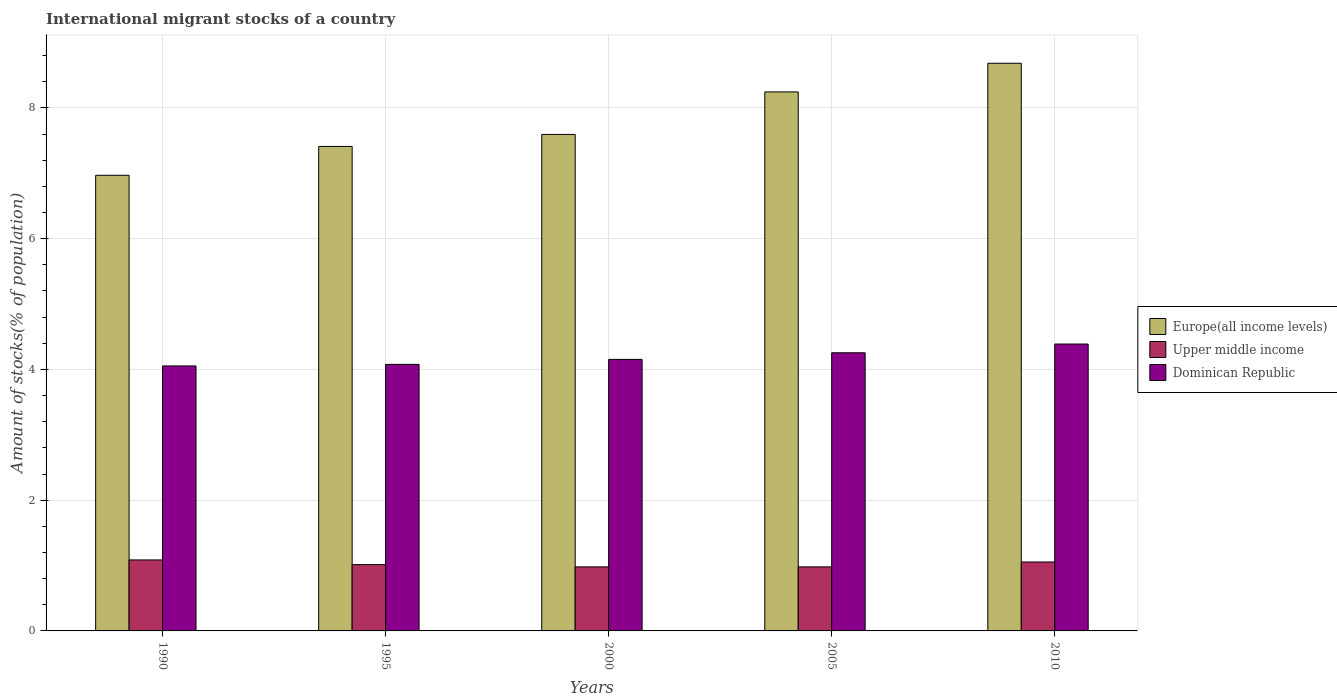Are the number of bars per tick equal to the number of legend labels?
Offer a very short reply. Yes. How many bars are there on the 4th tick from the left?
Provide a succinct answer. 3. How many bars are there on the 5th tick from the right?
Keep it short and to the point. 3. In how many cases, is the number of bars for a given year not equal to the number of legend labels?
Keep it short and to the point. 0. What is the amount of stocks in in Europe(all income levels) in 1990?
Your response must be concise. 6.97. Across all years, what is the maximum amount of stocks in in Europe(all income levels)?
Your answer should be compact. 8.68. Across all years, what is the minimum amount of stocks in in Upper middle income?
Offer a terse response. 0.98. What is the total amount of stocks in in Upper middle income in the graph?
Provide a short and direct response. 5.11. What is the difference between the amount of stocks in in Dominican Republic in 1990 and that in 2005?
Provide a short and direct response. -0.2. What is the difference between the amount of stocks in in Upper middle income in 2000 and the amount of stocks in in Dominican Republic in 2010?
Your answer should be very brief. -3.41. What is the average amount of stocks in in Dominican Republic per year?
Give a very brief answer. 4.19. In the year 2000, what is the difference between the amount of stocks in in Upper middle income and amount of stocks in in Europe(all income levels)?
Your response must be concise. -6.61. In how many years, is the amount of stocks in in Upper middle income greater than 2.8 %?
Provide a short and direct response. 0. What is the ratio of the amount of stocks in in Dominican Republic in 1990 to that in 2000?
Provide a succinct answer. 0.98. Is the amount of stocks in in Upper middle income in 1995 less than that in 2005?
Offer a very short reply. No. Is the difference between the amount of stocks in in Upper middle income in 1990 and 2005 greater than the difference between the amount of stocks in in Europe(all income levels) in 1990 and 2005?
Your answer should be compact. Yes. What is the difference between the highest and the second highest amount of stocks in in Upper middle income?
Provide a succinct answer. 0.03. What is the difference between the highest and the lowest amount of stocks in in Upper middle income?
Your answer should be very brief. 0.11. In how many years, is the amount of stocks in in Dominican Republic greater than the average amount of stocks in in Dominican Republic taken over all years?
Your answer should be very brief. 2. What does the 2nd bar from the left in 2000 represents?
Give a very brief answer. Upper middle income. What does the 1st bar from the right in 1995 represents?
Provide a succinct answer. Dominican Republic. Is it the case that in every year, the sum of the amount of stocks in in Dominican Republic and amount of stocks in in Upper middle income is greater than the amount of stocks in in Europe(all income levels)?
Offer a very short reply. No. What is the difference between two consecutive major ticks on the Y-axis?
Provide a succinct answer. 2. Where does the legend appear in the graph?
Your answer should be very brief. Center right. How many legend labels are there?
Provide a succinct answer. 3. How are the legend labels stacked?
Ensure brevity in your answer.  Vertical. What is the title of the graph?
Your answer should be compact. International migrant stocks of a country. Does "Kiribati" appear as one of the legend labels in the graph?
Provide a short and direct response. No. What is the label or title of the X-axis?
Provide a succinct answer. Years. What is the label or title of the Y-axis?
Give a very brief answer. Amount of stocks(% of population). What is the Amount of stocks(% of population) of Europe(all income levels) in 1990?
Keep it short and to the point. 6.97. What is the Amount of stocks(% of population) of Upper middle income in 1990?
Provide a short and direct response. 1.09. What is the Amount of stocks(% of population) in Dominican Republic in 1990?
Your response must be concise. 4.05. What is the Amount of stocks(% of population) in Europe(all income levels) in 1995?
Give a very brief answer. 7.41. What is the Amount of stocks(% of population) in Upper middle income in 1995?
Give a very brief answer. 1.01. What is the Amount of stocks(% of population) in Dominican Republic in 1995?
Make the answer very short. 4.08. What is the Amount of stocks(% of population) of Europe(all income levels) in 2000?
Provide a succinct answer. 7.59. What is the Amount of stocks(% of population) in Upper middle income in 2000?
Offer a very short reply. 0.98. What is the Amount of stocks(% of population) in Dominican Republic in 2000?
Provide a succinct answer. 4.15. What is the Amount of stocks(% of population) of Europe(all income levels) in 2005?
Offer a terse response. 8.24. What is the Amount of stocks(% of population) in Upper middle income in 2005?
Your answer should be very brief. 0.98. What is the Amount of stocks(% of population) in Dominican Republic in 2005?
Your answer should be very brief. 4.25. What is the Amount of stocks(% of population) in Europe(all income levels) in 2010?
Provide a succinct answer. 8.68. What is the Amount of stocks(% of population) in Upper middle income in 2010?
Make the answer very short. 1.05. What is the Amount of stocks(% of population) in Dominican Republic in 2010?
Your answer should be very brief. 4.39. Across all years, what is the maximum Amount of stocks(% of population) in Europe(all income levels)?
Offer a very short reply. 8.68. Across all years, what is the maximum Amount of stocks(% of population) of Upper middle income?
Offer a very short reply. 1.09. Across all years, what is the maximum Amount of stocks(% of population) of Dominican Republic?
Offer a very short reply. 4.39. Across all years, what is the minimum Amount of stocks(% of population) in Europe(all income levels)?
Provide a short and direct response. 6.97. Across all years, what is the minimum Amount of stocks(% of population) of Upper middle income?
Provide a short and direct response. 0.98. Across all years, what is the minimum Amount of stocks(% of population) in Dominican Republic?
Keep it short and to the point. 4.05. What is the total Amount of stocks(% of population) of Europe(all income levels) in the graph?
Provide a short and direct response. 38.9. What is the total Amount of stocks(% of population) in Upper middle income in the graph?
Make the answer very short. 5.11. What is the total Amount of stocks(% of population) of Dominican Republic in the graph?
Keep it short and to the point. 20.93. What is the difference between the Amount of stocks(% of population) in Europe(all income levels) in 1990 and that in 1995?
Keep it short and to the point. -0.44. What is the difference between the Amount of stocks(% of population) of Upper middle income in 1990 and that in 1995?
Ensure brevity in your answer.  0.07. What is the difference between the Amount of stocks(% of population) of Dominican Republic in 1990 and that in 1995?
Your answer should be compact. -0.02. What is the difference between the Amount of stocks(% of population) of Europe(all income levels) in 1990 and that in 2000?
Your answer should be compact. -0.62. What is the difference between the Amount of stocks(% of population) in Upper middle income in 1990 and that in 2000?
Your answer should be compact. 0.11. What is the difference between the Amount of stocks(% of population) of Dominican Republic in 1990 and that in 2000?
Offer a very short reply. -0.1. What is the difference between the Amount of stocks(% of population) in Europe(all income levels) in 1990 and that in 2005?
Give a very brief answer. -1.28. What is the difference between the Amount of stocks(% of population) of Upper middle income in 1990 and that in 2005?
Offer a terse response. 0.11. What is the difference between the Amount of stocks(% of population) of Dominican Republic in 1990 and that in 2005?
Offer a terse response. -0.2. What is the difference between the Amount of stocks(% of population) of Europe(all income levels) in 1990 and that in 2010?
Your answer should be very brief. -1.71. What is the difference between the Amount of stocks(% of population) of Upper middle income in 1990 and that in 2010?
Offer a very short reply. 0.03. What is the difference between the Amount of stocks(% of population) in Dominican Republic in 1990 and that in 2010?
Keep it short and to the point. -0.34. What is the difference between the Amount of stocks(% of population) of Europe(all income levels) in 1995 and that in 2000?
Provide a short and direct response. -0.18. What is the difference between the Amount of stocks(% of population) in Upper middle income in 1995 and that in 2000?
Make the answer very short. 0.03. What is the difference between the Amount of stocks(% of population) in Dominican Republic in 1995 and that in 2000?
Your answer should be very brief. -0.08. What is the difference between the Amount of stocks(% of population) in Europe(all income levels) in 1995 and that in 2005?
Offer a very short reply. -0.83. What is the difference between the Amount of stocks(% of population) in Upper middle income in 1995 and that in 2005?
Give a very brief answer. 0.04. What is the difference between the Amount of stocks(% of population) in Dominican Republic in 1995 and that in 2005?
Your answer should be very brief. -0.18. What is the difference between the Amount of stocks(% of population) in Europe(all income levels) in 1995 and that in 2010?
Offer a terse response. -1.27. What is the difference between the Amount of stocks(% of population) in Upper middle income in 1995 and that in 2010?
Keep it short and to the point. -0.04. What is the difference between the Amount of stocks(% of population) in Dominican Republic in 1995 and that in 2010?
Provide a short and direct response. -0.31. What is the difference between the Amount of stocks(% of population) in Europe(all income levels) in 2000 and that in 2005?
Offer a very short reply. -0.65. What is the difference between the Amount of stocks(% of population) of Upper middle income in 2000 and that in 2005?
Your answer should be compact. 0. What is the difference between the Amount of stocks(% of population) in Dominican Republic in 2000 and that in 2005?
Your answer should be compact. -0.1. What is the difference between the Amount of stocks(% of population) of Europe(all income levels) in 2000 and that in 2010?
Provide a succinct answer. -1.09. What is the difference between the Amount of stocks(% of population) of Upper middle income in 2000 and that in 2010?
Keep it short and to the point. -0.07. What is the difference between the Amount of stocks(% of population) of Dominican Republic in 2000 and that in 2010?
Provide a succinct answer. -0.24. What is the difference between the Amount of stocks(% of population) of Europe(all income levels) in 2005 and that in 2010?
Your response must be concise. -0.44. What is the difference between the Amount of stocks(% of population) of Upper middle income in 2005 and that in 2010?
Give a very brief answer. -0.07. What is the difference between the Amount of stocks(% of population) in Dominican Republic in 2005 and that in 2010?
Keep it short and to the point. -0.13. What is the difference between the Amount of stocks(% of population) of Europe(all income levels) in 1990 and the Amount of stocks(% of population) of Upper middle income in 1995?
Give a very brief answer. 5.96. What is the difference between the Amount of stocks(% of population) of Europe(all income levels) in 1990 and the Amount of stocks(% of population) of Dominican Republic in 1995?
Give a very brief answer. 2.89. What is the difference between the Amount of stocks(% of population) in Upper middle income in 1990 and the Amount of stocks(% of population) in Dominican Republic in 1995?
Provide a succinct answer. -2.99. What is the difference between the Amount of stocks(% of population) of Europe(all income levels) in 1990 and the Amount of stocks(% of population) of Upper middle income in 2000?
Keep it short and to the point. 5.99. What is the difference between the Amount of stocks(% of population) in Europe(all income levels) in 1990 and the Amount of stocks(% of population) in Dominican Republic in 2000?
Offer a terse response. 2.82. What is the difference between the Amount of stocks(% of population) in Upper middle income in 1990 and the Amount of stocks(% of population) in Dominican Republic in 2000?
Keep it short and to the point. -3.07. What is the difference between the Amount of stocks(% of population) of Europe(all income levels) in 1990 and the Amount of stocks(% of population) of Upper middle income in 2005?
Your answer should be very brief. 5.99. What is the difference between the Amount of stocks(% of population) of Europe(all income levels) in 1990 and the Amount of stocks(% of population) of Dominican Republic in 2005?
Your answer should be compact. 2.71. What is the difference between the Amount of stocks(% of population) of Upper middle income in 1990 and the Amount of stocks(% of population) of Dominican Republic in 2005?
Give a very brief answer. -3.17. What is the difference between the Amount of stocks(% of population) in Europe(all income levels) in 1990 and the Amount of stocks(% of population) in Upper middle income in 2010?
Your answer should be compact. 5.92. What is the difference between the Amount of stocks(% of population) of Europe(all income levels) in 1990 and the Amount of stocks(% of population) of Dominican Republic in 2010?
Ensure brevity in your answer.  2.58. What is the difference between the Amount of stocks(% of population) of Upper middle income in 1990 and the Amount of stocks(% of population) of Dominican Republic in 2010?
Provide a succinct answer. -3.3. What is the difference between the Amount of stocks(% of population) of Europe(all income levels) in 1995 and the Amount of stocks(% of population) of Upper middle income in 2000?
Offer a very short reply. 6.43. What is the difference between the Amount of stocks(% of population) in Europe(all income levels) in 1995 and the Amount of stocks(% of population) in Dominican Republic in 2000?
Provide a succinct answer. 3.26. What is the difference between the Amount of stocks(% of population) of Upper middle income in 1995 and the Amount of stocks(% of population) of Dominican Republic in 2000?
Make the answer very short. -3.14. What is the difference between the Amount of stocks(% of population) in Europe(all income levels) in 1995 and the Amount of stocks(% of population) in Upper middle income in 2005?
Make the answer very short. 6.43. What is the difference between the Amount of stocks(% of population) in Europe(all income levels) in 1995 and the Amount of stocks(% of population) in Dominican Republic in 2005?
Your answer should be very brief. 3.16. What is the difference between the Amount of stocks(% of population) of Upper middle income in 1995 and the Amount of stocks(% of population) of Dominican Republic in 2005?
Keep it short and to the point. -3.24. What is the difference between the Amount of stocks(% of population) in Europe(all income levels) in 1995 and the Amount of stocks(% of population) in Upper middle income in 2010?
Ensure brevity in your answer.  6.36. What is the difference between the Amount of stocks(% of population) in Europe(all income levels) in 1995 and the Amount of stocks(% of population) in Dominican Republic in 2010?
Your answer should be compact. 3.02. What is the difference between the Amount of stocks(% of population) in Upper middle income in 1995 and the Amount of stocks(% of population) in Dominican Republic in 2010?
Your answer should be compact. -3.37. What is the difference between the Amount of stocks(% of population) of Europe(all income levels) in 2000 and the Amount of stocks(% of population) of Upper middle income in 2005?
Make the answer very short. 6.62. What is the difference between the Amount of stocks(% of population) of Europe(all income levels) in 2000 and the Amount of stocks(% of population) of Dominican Republic in 2005?
Make the answer very short. 3.34. What is the difference between the Amount of stocks(% of population) of Upper middle income in 2000 and the Amount of stocks(% of population) of Dominican Republic in 2005?
Keep it short and to the point. -3.27. What is the difference between the Amount of stocks(% of population) of Europe(all income levels) in 2000 and the Amount of stocks(% of population) of Upper middle income in 2010?
Keep it short and to the point. 6.54. What is the difference between the Amount of stocks(% of population) in Europe(all income levels) in 2000 and the Amount of stocks(% of population) in Dominican Republic in 2010?
Ensure brevity in your answer.  3.21. What is the difference between the Amount of stocks(% of population) in Upper middle income in 2000 and the Amount of stocks(% of population) in Dominican Republic in 2010?
Your answer should be very brief. -3.41. What is the difference between the Amount of stocks(% of population) of Europe(all income levels) in 2005 and the Amount of stocks(% of population) of Upper middle income in 2010?
Ensure brevity in your answer.  7.19. What is the difference between the Amount of stocks(% of population) in Europe(all income levels) in 2005 and the Amount of stocks(% of population) in Dominican Republic in 2010?
Ensure brevity in your answer.  3.86. What is the difference between the Amount of stocks(% of population) of Upper middle income in 2005 and the Amount of stocks(% of population) of Dominican Republic in 2010?
Ensure brevity in your answer.  -3.41. What is the average Amount of stocks(% of population) of Europe(all income levels) per year?
Ensure brevity in your answer.  7.78. What is the average Amount of stocks(% of population) of Upper middle income per year?
Make the answer very short. 1.02. What is the average Amount of stocks(% of population) in Dominican Republic per year?
Keep it short and to the point. 4.19. In the year 1990, what is the difference between the Amount of stocks(% of population) in Europe(all income levels) and Amount of stocks(% of population) in Upper middle income?
Give a very brief answer. 5.88. In the year 1990, what is the difference between the Amount of stocks(% of population) in Europe(all income levels) and Amount of stocks(% of population) in Dominican Republic?
Ensure brevity in your answer.  2.92. In the year 1990, what is the difference between the Amount of stocks(% of population) of Upper middle income and Amount of stocks(% of population) of Dominican Republic?
Your response must be concise. -2.97. In the year 1995, what is the difference between the Amount of stocks(% of population) of Europe(all income levels) and Amount of stocks(% of population) of Upper middle income?
Offer a very short reply. 6.4. In the year 1995, what is the difference between the Amount of stocks(% of population) in Europe(all income levels) and Amount of stocks(% of population) in Dominican Republic?
Provide a succinct answer. 3.33. In the year 1995, what is the difference between the Amount of stocks(% of population) of Upper middle income and Amount of stocks(% of population) of Dominican Republic?
Give a very brief answer. -3.06. In the year 2000, what is the difference between the Amount of stocks(% of population) in Europe(all income levels) and Amount of stocks(% of population) in Upper middle income?
Give a very brief answer. 6.61. In the year 2000, what is the difference between the Amount of stocks(% of population) of Europe(all income levels) and Amount of stocks(% of population) of Dominican Republic?
Offer a terse response. 3.44. In the year 2000, what is the difference between the Amount of stocks(% of population) in Upper middle income and Amount of stocks(% of population) in Dominican Republic?
Your answer should be very brief. -3.17. In the year 2005, what is the difference between the Amount of stocks(% of population) in Europe(all income levels) and Amount of stocks(% of population) in Upper middle income?
Provide a short and direct response. 7.27. In the year 2005, what is the difference between the Amount of stocks(% of population) in Europe(all income levels) and Amount of stocks(% of population) in Dominican Republic?
Your answer should be compact. 3.99. In the year 2005, what is the difference between the Amount of stocks(% of population) in Upper middle income and Amount of stocks(% of population) in Dominican Republic?
Your response must be concise. -3.28. In the year 2010, what is the difference between the Amount of stocks(% of population) in Europe(all income levels) and Amount of stocks(% of population) in Upper middle income?
Provide a short and direct response. 7.63. In the year 2010, what is the difference between the Amount of stocks(% of population) of Europe(all income levels) and Amount of stocks(% of population) of Dominican Republic?
Offer a terse response. 4.29. In the year 2010, what is the difference between the Amount of stocks(% of population) of Upper middle income and Amount of stocks(% of population) of Dominican Republic?
Give a very brief answer. -3.33. What is the ratio of the Amount of stocks(% of population) of Europe(all income levels) in 1990 to that in 1995?
Offer a very short reply. 0.94. What is the ratio of the Amount of stocks(% of population) of Upper middle income in 1990 to that in 1995?
Provide a succinct answer. 1.07. What is the ratio of the Amount of stocks(% of population) of Dominican Republic in 1990 to that in 1995?
Your answer should be compact. 0.99. What is the ratio of the Amount of stocks(% of population) of Europe(all income levels) in 1990 to that in 2000?
Offer a very short reply. 0.92. What is the ratio of the Amount of stocks(% of population) of Upper middle income in 1990 to that in 2000?
Give a very brief answer. 1.11. What is the ratio of the Amount of stocks(% of population) in Dominican Republic in 1990 to that in 2000?
Offer a very short reply. 0.98. What is the ratio of the Amount of stocks(% of population) in Europe(all income levels) in 1990 to that in 2005?
Provide a succinct answer. 0.85. What is the ratio of the Amount of stocks(% of population) in Upper middle income in 1990 to that in 2005?
Keep it short and to the point. 1.11. What is the ratio of the Amount of stocks(% of population) in Dominican Republic in 1990 to that in 2005?
Your response must be concise. 0.95. What is the ratio of the Amount of stocks(% of population) of Europe(all income levels) in 1990 to that in 2010?
Keep it short and to the point. 0.8. What is the ratio of the Amount of stocks(% of population) in Dominican Republic in 1990 to that in 2010?
Keep it short and to the point. 0.92. What is the ratio of the Amount of stocks(% of population) of Europe(all income levels) in 1995 to that in 2000?
Your response must be concise. 0.98. What is the ratio of the Amount of stocks(% of population) in Upper middle income in 1995 to that in 2000?
Your answer should be compact. 1.04. What is the ratio of the Amount of stocks(% of population) in Dominican Republic in 1995 to that in 2000?
Offer a very short reply. 0.98. What is the ratio of the Amount of stocks(% of population) of Europe(all income levels) in 1995 to that in 2005?
Provide a short and direct response. 0.9. What is the ratio of the Amount of stocks(% of population) of Upper middle income in 1995 to that in 2005?
Your answer should be very brief. 1.04. What is the ratio of the Amount of stocks(% of population) of Dominican Republic in 1995 to that in 2005?
Ensure brevity in your answer.  0.96. What is the ratio of the Amount of stocks(% of population) in Europe(all income levels) in 1995 to that in 2010?
Your response must be concise. 0.85. What is the ratio of the Amount of stocks(% of population) in Upper middle income in 1995 to that in 2010?
Ensure brevity in your answer.  0.96. What is the ratio of the Amount of stocks(% of population) of Dominican Republic in 1995 to that in 2010?
Your response must be concise. 0.93. What is the ratio of the Amount of stocks(% of population) of Europe(all income levels) in 2000 to that in 2005?
Offer a terse response. 0.92. What is the ratio of the Amount of stocks(% of population) of Upper middle income in 2000 to that in 2005?
Your answer should be compact. 1. What is the ratio of the Amount of stocks(% of population) in Dominican Republic in 2000 to that in 2005?
Your response must be concise. 0.98. What is the ratio of the Amount of stocks(% of population) in Europe(all income levels) in 2000 to that in 2010?
Give a very brief answer. 0.87. What is the ratio of the Amount of stocks(% of population) in Upper middle income in 2000 to that in 2010?
Offer a terse response. 0.93. What is the ratio of the Amount of stocks(% of population) of Dominican Republic in 2000 to that in 2010?
Make the answer very short. 0.95. What is the ratio of the Amount of stocks(% of population) of Europe(all income levels) in 2005 to that in 2010?
Your answer should be very brief. 0.95. What is the ratio of the Amount of stocks(% of population) of Upper middle income in 2005 to that in 2010?
Give a very brief answer. 0.93. What is the ratio of the Amount of stocks(% of population) of Dominican Republic in 2005 to that in 2010?
Provide a short and direct response. 0.97. What is the difference between the highest and the second highest Amount of stocks(% of population) of Europe(all income levels)?
Offer a very short reply. 0.44. What is the difference between the highest and the second highest Amount of stocks(% of population) in Upper middle income?
Your answer should be very brief. 0.03. What is the difference between the highest and the second highest Amount of stocks(% of population) in Dominican Republic?
Ensure brevity in your answer.  0.13. What is the difference between the highest and the lowest Amount of stocks(% of population) in Europe(all income levels)?
Provide a short and direct response. 1.71. What is the difference between the highest and the lowest Amount of stocks(% of population) of Upper middle income?
Make the answer very short. 0.11. What is the difference between the highest and the lowest Amount of stocks(% of population) of Dominican Republic?
Make the answer very short. 0.34. 